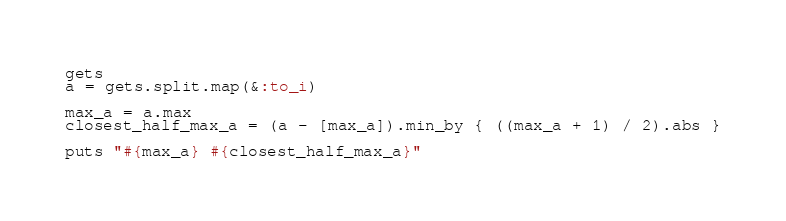<code> <loc_0><loc_0><loc_500><loc_500><_Ruby_>gets
a = gets.split.map(&:to_i)

max_a = a.max
closest_half_max_a = (a - [max_a]).min_by { ((max_a + 1) / 2).abs }

puts "#{max_a} #{closest_half_max_a}"</code> 